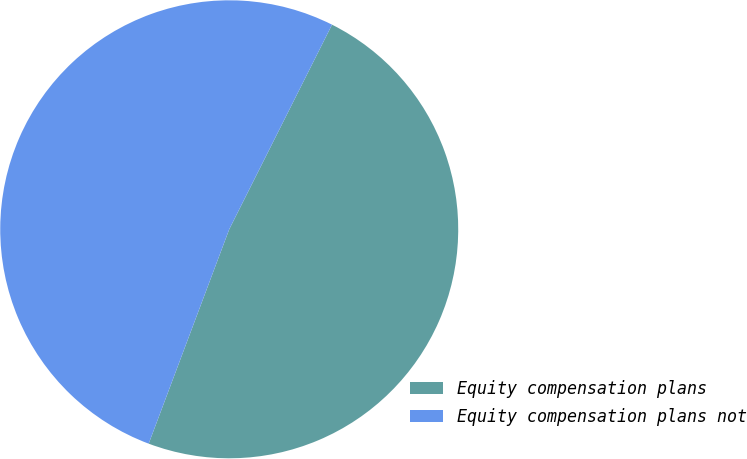Convert chart to OTSL. <chart><loc_0><loc_0><loc_500><loc_500><pie_chart><fcel>Equity compensation plans<fcel>Equity compensation plans not<nl><fcel>48.31%<fcel>51.69%<nl></chart> 